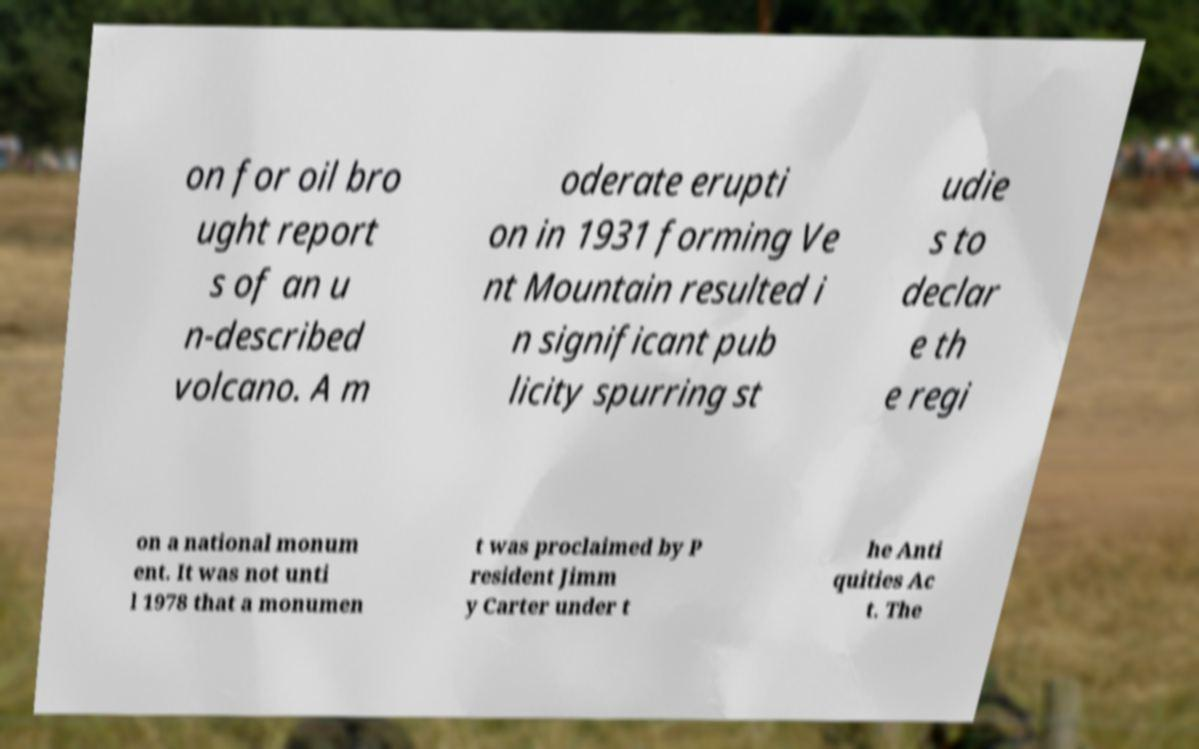There's text embedded in this image that I need extracted. Can you transcribe it verbatim? on for oil bro ught report s of an u n-described volcano. A m oderate erupti on in 1931 forming Ve nt Mountain resulted i n significant pub licity spurring st udie s to declar e th e regi on a national monum ent. It was not unti l 1978 that a monumen t was proclaimed by P resident Jimm y Carter under t he Anti quities Ac t. The 